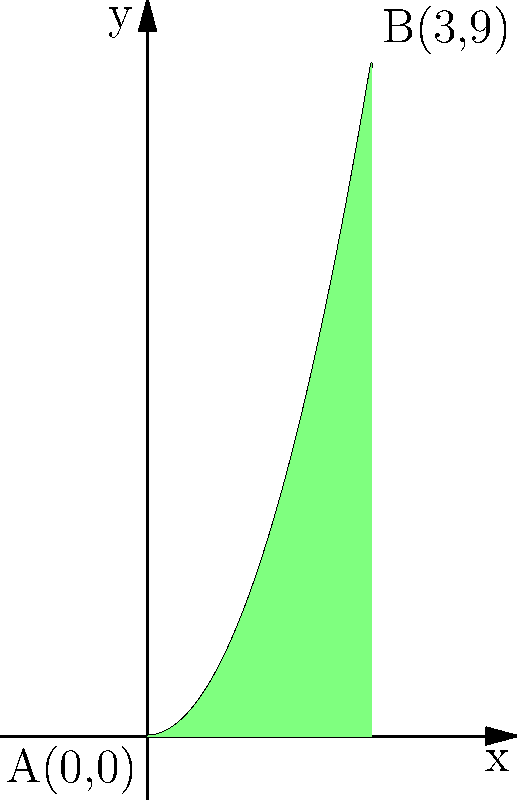A particle moves along the curve $y = x^2$ from point A(0,0) to point B(3,9). The force acting on the particle is given by $F(x) = 2x + 1$ N in the positive x-direction. Calculate the work done by this force on the particle as it moves from A to B. To solve this problem, we'll follow these steps:

1) The work done by a variable force $F(x)$ along a curve is given by the formula:

   $W = \int_{a}^{b} F(x) \, ds$

   where $ds$ is the differential arc length.

2) For a curve given by $y = f(x)$, the differential arc length is:

   $ds = \sqrt{1 + [f'(x)]^2} \, dx$

3) In our case, $y = x^2$, so $f'(x) = 2x$. Therefore:

   $ds = \sqrt{1 + (2x)^2} \, dx = \sqrt{1 + 4x^2} \, dx$

4) Now, we can set up our integral:

   $W = \int_{0}^{3} (2x + 1) \sqrt{1 + 4x^2} \, dx$

5) This integral is quite complex to solve by hand. In a clinical setting, we might use numerical integration methods or a computer algebra system. The exact result is:

   $W = \frac{1}{12}(9\sqrt{37} + 2\sqrt{1} - 11) + \frac{1}{6}(27\sqrt{37} - \sqrt{1} - 26)$

6) Simplifying:

   $W = 3\sqrt{37} - 3 \approx 15.23$ J

Therefore, the work done by the force on the particle is approximately 15.23 Joules.
Answer: $3\sqrt{37} - 3$ J 